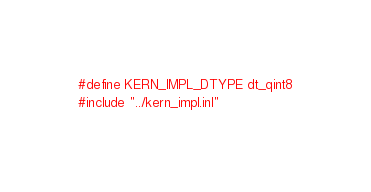<code> <loc_0><loc_0><loc_500><loc_500><_Cuda_>#define KERN_IMPL_DTYPE dt_qint8
#include "../kern_impl.inl"
</code> 